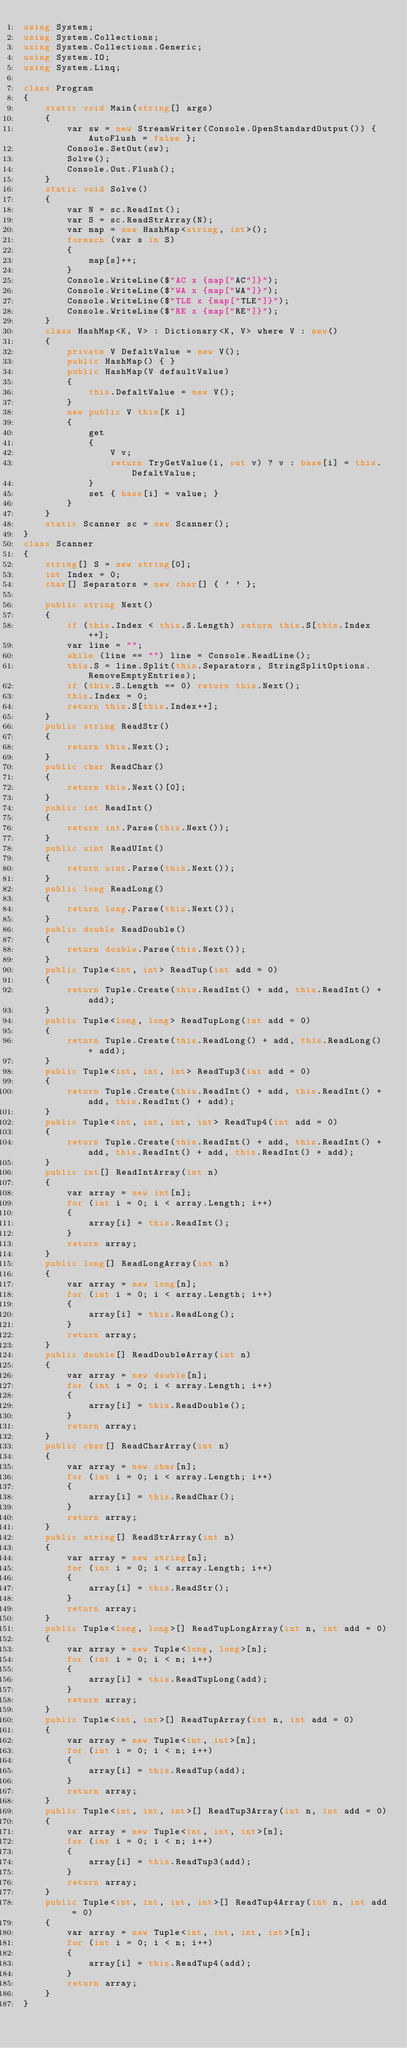<code> <loc_0><loc_0><loc_500><loc_500><_C#_>using System;
using System.Collections;
using System.Collections.Generic;
using System.IO;
using System.Linq;

class Program
{
    static void Main(string[] args)
    {
        var sw = new StreamWriter(Console.OpenStandardOutput()) { AutoFlush = false };
        Console.SetOut(sw);
        Solve();
        Console.Out.Flush();
    }
    static void Solve()
    {
        var N = sc.ReadInt();
        var S = sc.ReadStrArray(N);
        var map = new HashMap<string, int>();
        foreach (var s in S)
        {
            map[s]++;
        }
        Console.WriteLine($"AC x {map["AC"]}");
        Console.WriteLine($"WA x {map["WA"]}");
        Console.WriteLine($"TLE x {map["TLE"]}");
        Console.WriteLine($"RE x {map["RE"]}");
    }
    class HashMap<K, V> : Dictionary<K, V> where V : new()
    {
        private V DefaltValue = new V();
        public HashMap() { }
        public HashMap(V defaultValue)
        {
            this.DefaltValue = new V();
        }
        new public V this[K i]
        {
            get
            {
                V v;
                return TryGetValue(i, out v) ? v : base[i] = this.DefaltValue;
            }
            set { base[i] = value; }
        }
    }
    static Scanner sc = new Scanner();
}
class Scanner
{
    string[] S = new string[0];
    int Index = 0;
    char[] Separators = new char[] { ' ' };

    public string Next()
    {
        if (this.Index < this.S.Length) return this.S[this.Index++];
        var line = "";
        while (line == "") line = Console.ReadLine();
        this.S = line.Split(this.Separators, StringSplitOptions.RemoveEmptyEntries);
        if (this.S.Length == 0) return this.Next();
        this.Index = 0;
        return this.S[this.Index++];
    }
    public string ReadStr()
    {
        return this.Next();
    }
    public char ReadChar()
    {
        return this.Next()[0];
    }
    public int ReadInt()
    {
        return int.Parse(this.Next());
    }
    public uint ReadUInt()
    {
        return uint.Parse(this.Next());
    }
    public long ReadLong()
    {
        return long.Parse(this.Next());
    }
    public double ReadDouble()
    {
        return double.Parse(this.Next());
    }
    public Tuple<int, int> ReadTup(int add = 0)
    {
        return Tuple.Create(this.ReadInt() + add, this.ReadInt() + add);
    }
    public Tuple<long, long> ReadTupLong(int add = 0)
    {
        return Tuple.Create(this.ReadLong() + add, this.ReadLong() + add);
    }
    public Tuple<int, int, int> ReadTup3(int add = 0)
    {
        return Tuple.Create(this.ReadInt() + add, this.ReadInt() + add, this.ReadInt() + add);
    }
    public Tuple<int, int, int, int> ReadTup4(int add = 0)
    {
        return Tuple.Create(this.ReadInt() + add, this.ReadInt() + add, this.ReadInt() + add, this.ReadInt() + add);
    }
    public int[] ReadIntArray(int n)
    {
        var array = new int[n];
        for (int i = 0; i < array.Length; i++)
        {
            array[i] = this.ReadInt();
        }
        return array;
    }
    public long[] ReadLongArray(int n)
    {
        var array = new long[n];
        for (int i = 0; i < array.Length; i++)
        {
            array[i] = this.ReadLong();
        }
        return array;
    }
    public double[] ReadDoubleArray(int n)
    {
        var array = new double[n];
        for (int i = 0; i < array.Length; i++)
        {
            array[i] = this.ReadDouble();
        }
        return array;
    }
    public char[] ReadCharArray(int n)
    {
        var array = new char[n];
        for (int i = 0; i < array.Length; i++)
        {
            array[i] = this.ReadChar();
        }
        return array;
    }
    public string[] ReadStrArray(int n)
    {
        var array = new string[n];
        for (int i = 0; i < array.Length; i++)
        {
            array[i] = this.ReadStr();
        }
        return array;
    }
    public Tuple<long, long>[] ReadTupLongArray(int n, int add = 0)
    {
        var array = new Tuple<long, long>[n];
        for (int i = 0; i < n; i++)
        {
            array[i] = this.ReadTupLong(add);
        }
        return array;
    }
    public Tuple<int, int>[] ReadTupArray(int n, int add = 0)
    {
        var array = new Tuple<int, int>[n];
        for (int i = 0; i < n; i++)
        {
            array[i] = this.ReadTup(add);
        }
        return array;
    }
    public Tuple<int, int, int>[] ReadTup3Array(int n, int add = 0)
    {
        var array = new Tuple<int, int, int>[n];
        for (int i = 0; i < n; i++)
        {
            array[i] = this.ReadTup3(add);
        }
        return array;
    }
    public Tuple<int, int, int, int>[] ReadTup4Array(int n, int add = 0)
    {
        var array = new Tuple<int, int, int, int>[n];
        for (int i = 0; i < n; i++)
        {
            array[i] = this.ReadTup4(add);
        }
        return array;
    }
}
</code> 